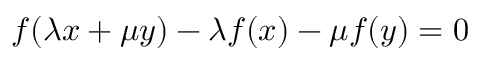Convert formula to latex. <formula><loc_0><loc_0><loc_500><loc_500>f ( \lambda x + \mu y ) - \lambda f ( x ) - \mu f ( y ) = 0</formula> 